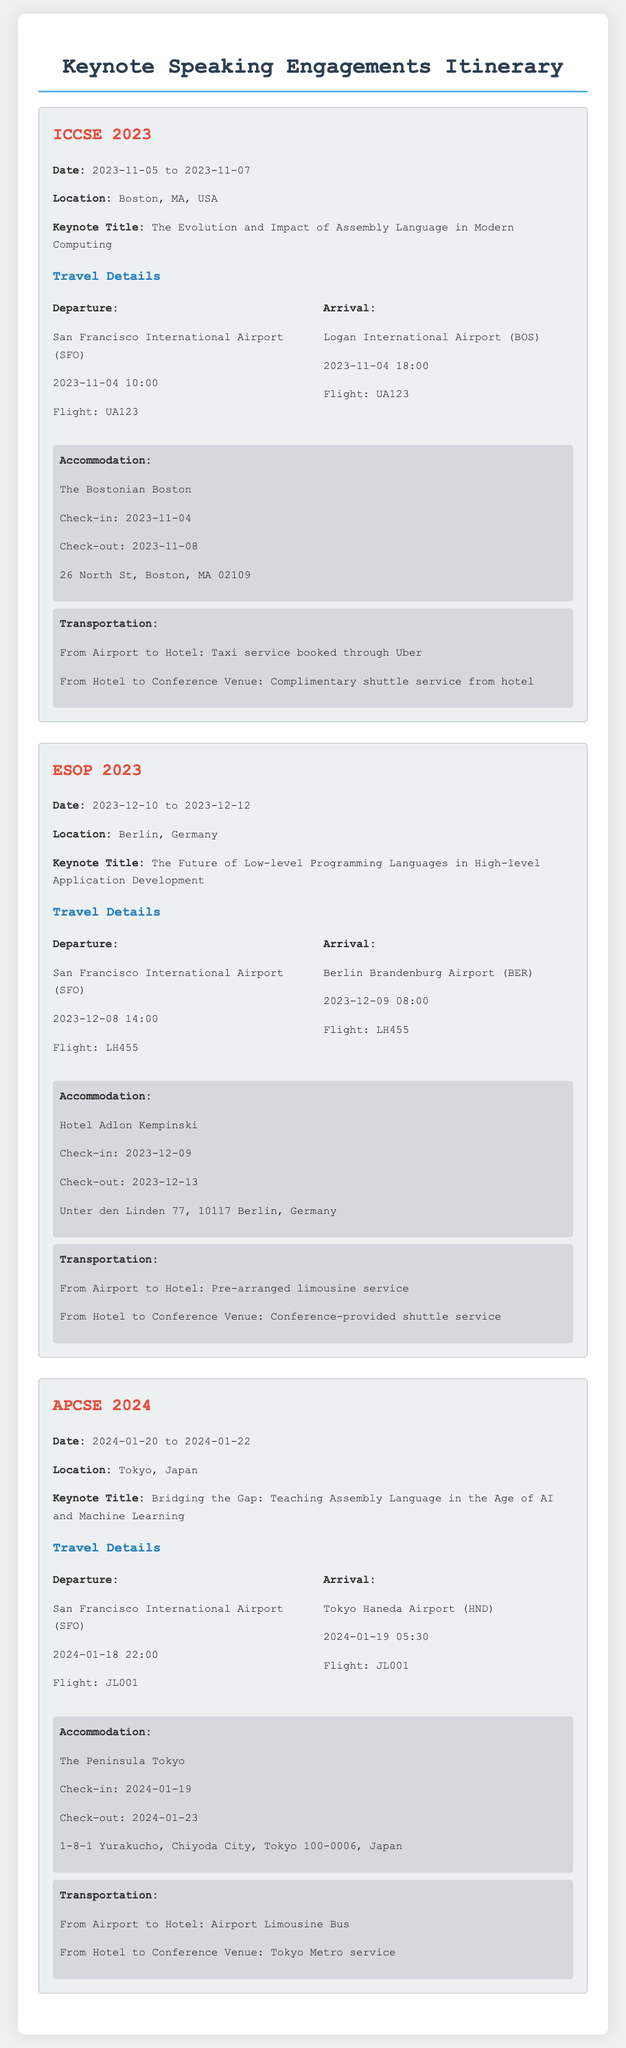What is the date of ICCSE 2023? The date of ICCSE 2023 is from November 5 to November 7, 2023.
Answer: November 5 to November 7, 2023 What is the keynote title for ESOP 2023? The keynote title for ESOP 2023 is "The Future of Low-level Programming Languages in High-level Application Development."
Answer: The Future of Low-level Programming Languages in High-level Application Development Where is the conference APCSE 2024 being held? APCSE 2024 is being held in Tokyo, Japan.
Answer: Tokyo, Japan What time is the departure for the ICCSE 2023 flight? The departure time for the ICCSE 2023 flight is at 10:00 on November 4, 2023.
Answer: 10:00 on November 4, 2023 Which hotel will be hosting the accommodation for ESOP 2023? The hotel hosting the accommodation for ESOP 2023 is the Hotel Adlon Kempinski.
Answer: Hotel Adlon Kempinski How will transportation from the hotel to the conference venue for APCSE 2024 be provided? Transportation from the hotel to the conference venue for APCSE 2024 will be provided by Tokyo Metro service.
Answer: Tokyo Metro service What is the check-out date for the accommodation at ICCSE 2023? The check-out date for the accommodation at ICCSE 2023 is November 8, 2023.
Answer: November 8, 2023 What flight number is scheduled for the departure to Berlin for ESOP 2023? The flight number scheduled for the departure to Berlin for ESOP 2023 is LH455.
Answer: LH455 